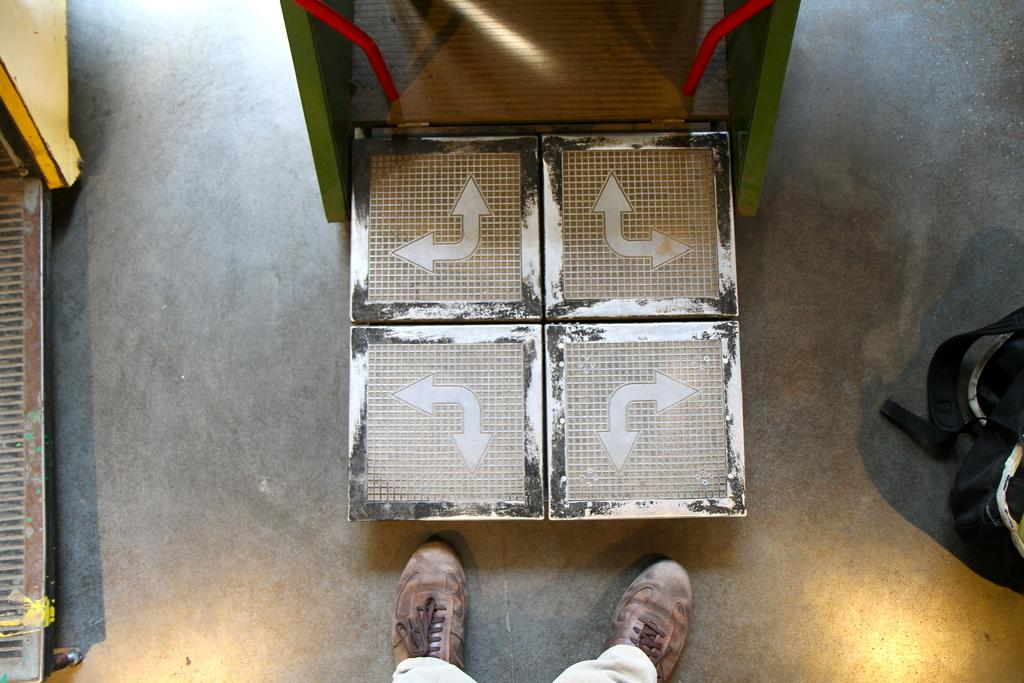What is on the floor in the image? There is a bag on the floor in the image. What else can be seen in the image besides the bag? There are two machines in the image. Can you describe the person in the image? The person has two legs visible in the image, and they are wearing brown shoes. Is the maid holding a turkey in the image? There is no maid or turkey present in the image. 